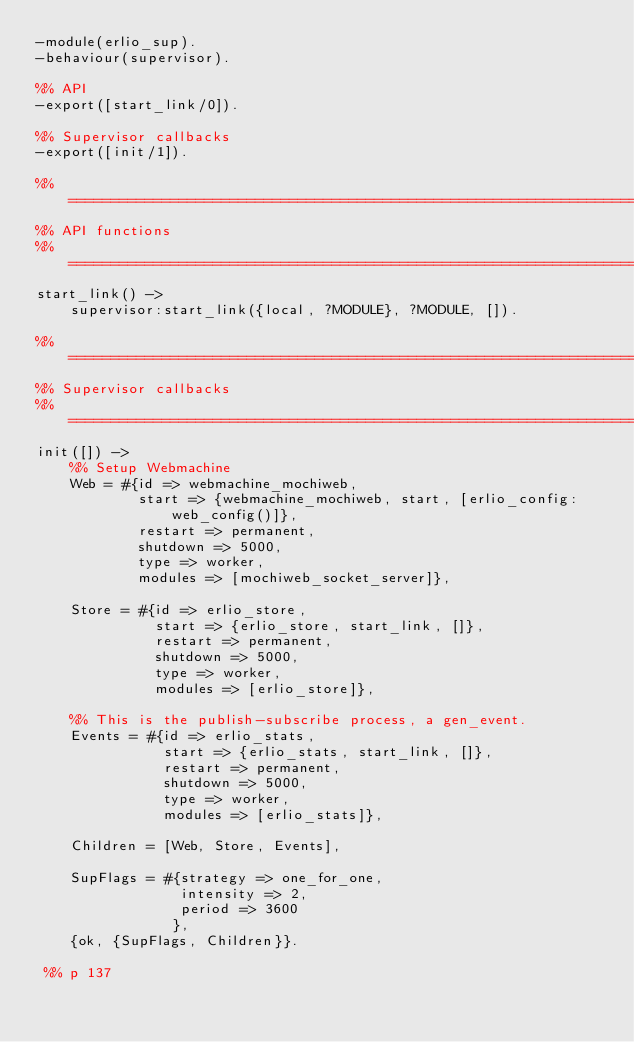Convert code to text. <code><loc_0><loc_0><loc_500><loc_500><_Erlang_>-module(erlio_sup).
-behaviour(supervisor).

%% API
-export([start_link/0]).

%% Supervisor callbacks
-export([init/1]).

%% ===================================================================
%% API functions
%% ===================================================================
start_link() ->
    supervisor:start_link({local, ?MODULE}, ?MODULE, []).

%% ===================================================================
%% Supervisor callbacks
%% ===================================================================
init([]) ->
    %% Setup Webmachine
    Web = #{id => webmachine_mochiweb,
            start => {webmachine_mochiweb, start, [erlio_config:web_config()]},
            restart => permanent, 
            shutdown => 5000, 
            type => worker, 
            modules => [mochiweb_socket_server]},

    Store = #{id => erlio_store,
              start => {erlio_store, start_link, []},
              restart => permanent, 
              shutdown => 5000, 
              type => worker, 
              modules => [erlio_store]},

    %% This is the publish-subscribe process, a gen_event.
    Events = #{id => erlio_stats,
               start => {erlio_stats, start_link, []},
               restart => permanent, 
               shutdown => 5000, 
               type => worker, 
               modules => [erlio_stats]},

    Children = [Web, Store, Events],
    
    SupFlags = #{strategy => one_for_one,
                 intensity => 2,
                 period => 3600
                },
    {ok, {SupFlags, Children}}.

 %% p 137
</code> 